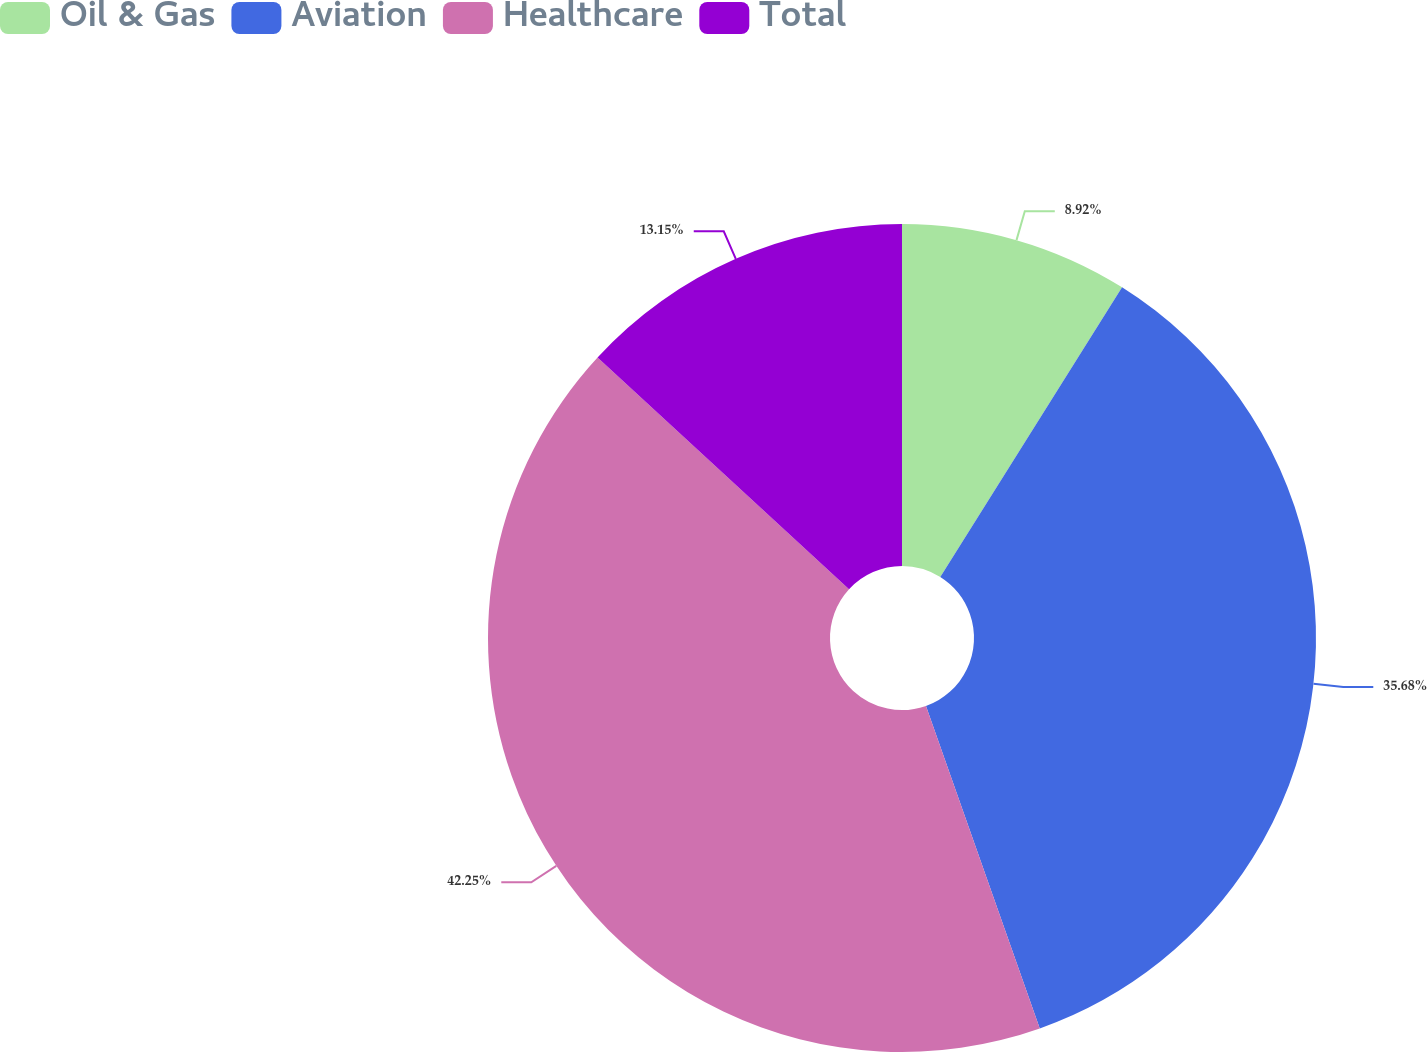Convert chart to OTSL. <chart><loc_0><loc_0><loc_500><loc_500><pie_chart><fcel>Oil & Gas<fcel>Aviation<fcel>Healthcare<fcel>Total<nl><fcel>8.92%<fcel>35.68%<fcel>42.25%<fcel>13.15%<nl></chart> 